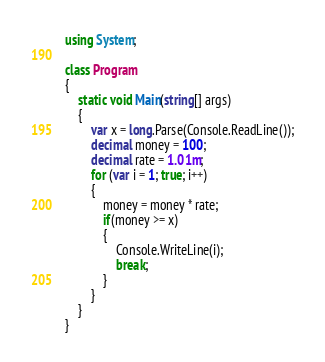<code> <loc_0><loc_0><loc_500><loc_500><_C#_>using System;

class Program
{
    static void Main(string[] args)
    {
        var x = long.Parse(Console.ReadLine());
        decimal money = 100;
        decimal rate = 1.01m;
        for (var i = 1; true; i++)
        {
            money = money * rate;
            if(money >= x)
            {
                Console.WriteLine(i);
                break;
            }
        }
    }
}</code> 